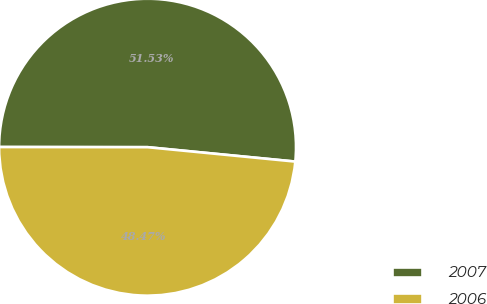<chart> <loc_0><loc_0><loc_500><loc_500><pie_chart><fcel>2007<fcel>2006<nl><fcel>51.53%<fcel>48.47%<nl></chart> 